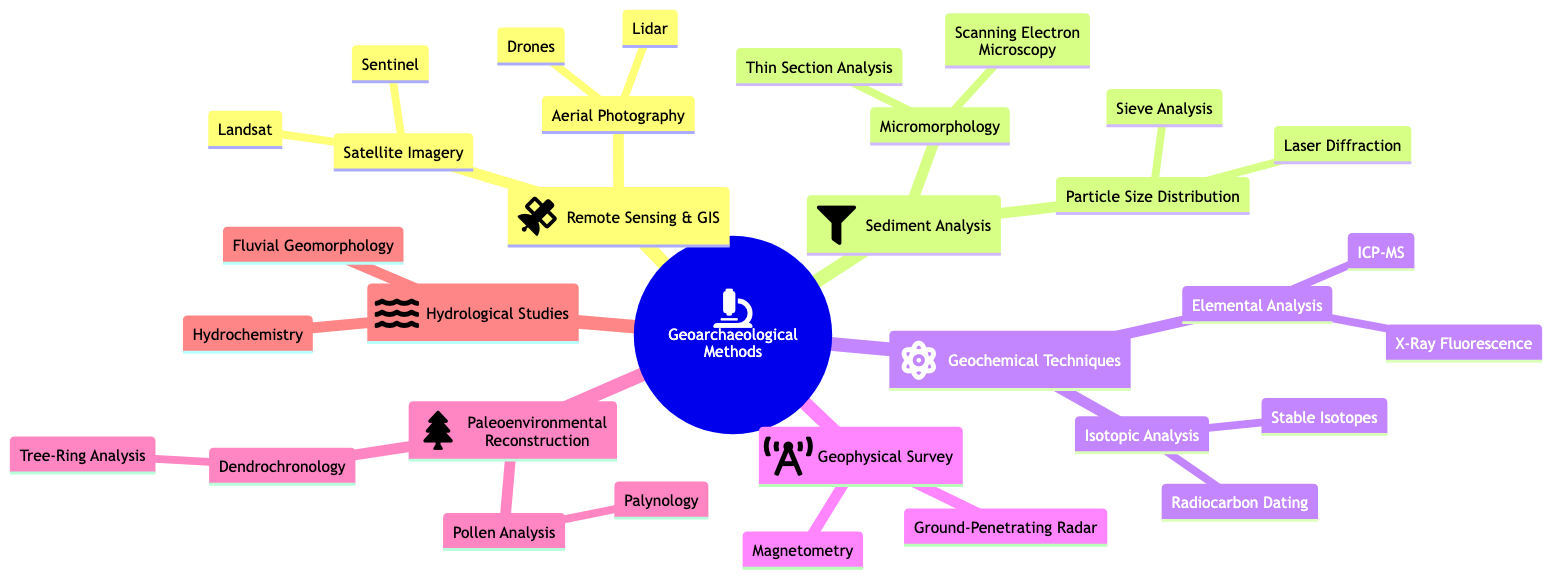What is the main category represented in the mind map? The central node is titled "Geoarchaeological Methods," which indicates that this is the primary category around which the diagram is organized.
Answer: Geoarchaeological Methods How many main categories are there under Geoarchaeological Methods? The diagram has five main categories branching from the central node, which are Remote Sensing & GIS, Sediment Analysis, Geochemical Techniques, Geophysical Survey, and Paleoenvironmental Reconstruction.
Answer: 5 Which technique is part of Geochemical Techniques? Under Geochemical Techniques, there are two specific subcategories: Elemental Analysis and Isotopic Analysis. One example of a technique within Elemental Analysis is X-Ray Fluorescence.
Answer: X-Ray Fluorescence What is the purpose of Pollen Analysis? According to the node, Pollen Analysis (Palynology) is utilized for reconstructing vegetation history and climate conditions, which implies it focuses on historical environmental analysis.
Answer: Vegetation history and climate reconstruction What are the two methods listed under Remote Sensing & GIS for Satellite Imagery? The diagram specifies that within Satellite Imagery under Remote Sensing & GIS, the two methods are "Landsat" and "Sentinel."
Answer: Landsat and Sentinel How many techniques are listed under Sediment Analysis? In the Sediment Analysis section, there are two main subcategories: Particle Size Distribution and Micromorphology. Each of these has two techniques listed, totaling four techniques.
Answer: 4 What is Ground-Penetrating Radar used for? The diagram states that Ground-Penetrating Radar (GPR) is a method used to reveal underground structures, illustrating its application in detecting features beneath the surface.
Answer: Reveals underground structures Which method involves determining grain size composition? The diagram indicates that "Laser Diffraction" is the method used for determining grain size composition within the Particle Size Distribution category under Sediment Analysis.
Answer: Laser Diffraction What type of analysis does Dendrochronology involve? The node explains that Dendrochronology focuses on Tree-Ring Analysis, a method for dating and providing insights into past climate conditions.
Answer: Tree-Ring Analysis 